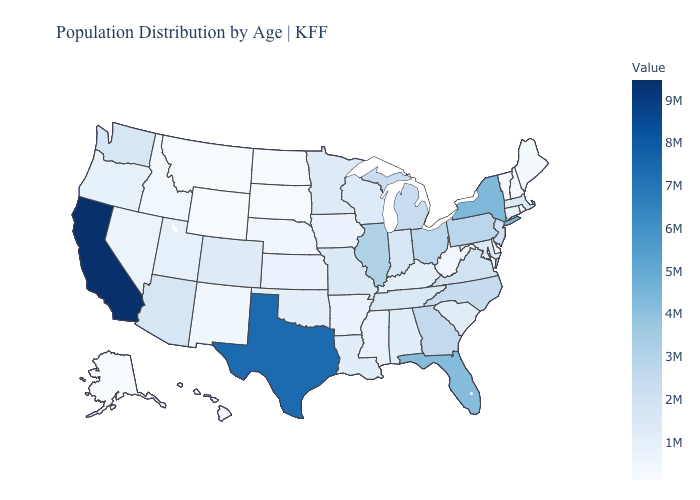Does Colorado have the highest value in the West?
Keep it brief. No. Does New Mexico have a higher value than Arizona?
Quick response, please. No. Is the legend a continuous bar?
Quick response, please. Yes. Among the states that border Wisconsin , which have the highest value?
Give a very brief answer. Illinois. Among the states that border Louisiana , which have the lowest value?
Answer briefly. Arkansas. Which states hav the highest value in the South?
Give a very brief answer. Texas. 